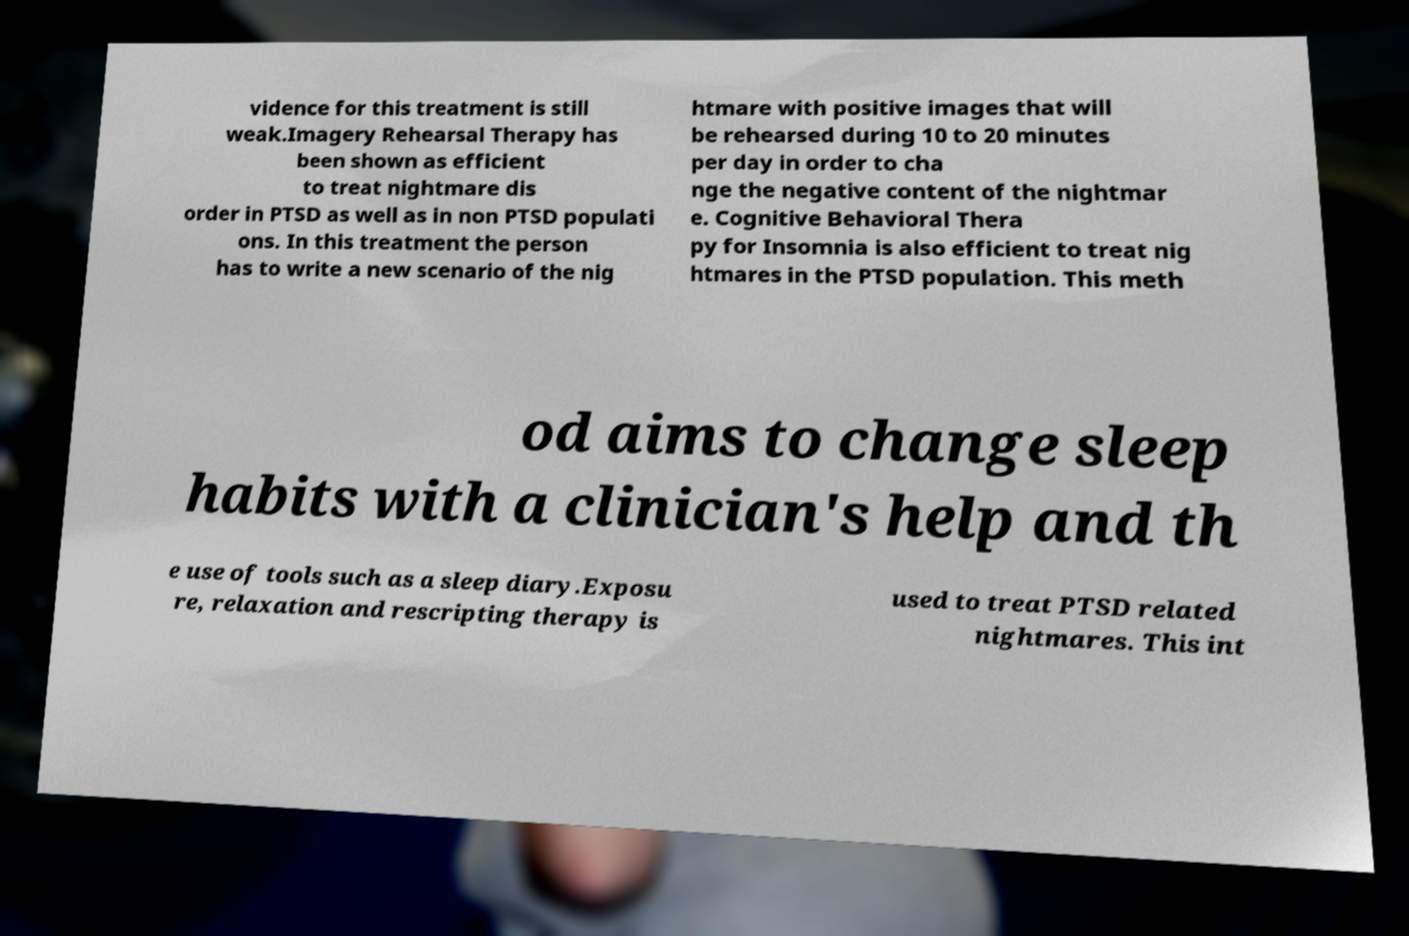For documentation purposes, I need the text within this image transcribed. Could you provide that? vidence for this treatment is still weak.Imagery Rehearsal Therapy has been shown as efficient to treat nightmare dis order in PTSD as well as in non PTSD populati ons. In this treatment the person has to write a new scenario of the nig htmare with positive images that will be rehearsed during 10 to 20 minutes per day in order to cha nge the negative content of the nightmar e. Cognitive Behavioral Thera py for Insomnia is also efficient to treat nig htmares in the PTSD population. This meth od aims to change sleep habits with a clinician's help and th e use of tools such as a sleep diary.Exposu re, relaxation and rescripting therapy is used to treat PTSD related nightmares. This int 